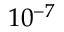Convert formula to latex. <formula><loc_0><loc_0><loc_500><loc_500>1 0 ^ { - 7 }</formula> 